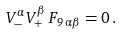Convert formula to latex. <formula><loc_0><loc_0><loc_500><loc_500>V ^ { \alpha } _ { - } V ^ { \beta } _ { + } \, F _ { 9 \, \alpha \beta } = 0 \, .</formula> 